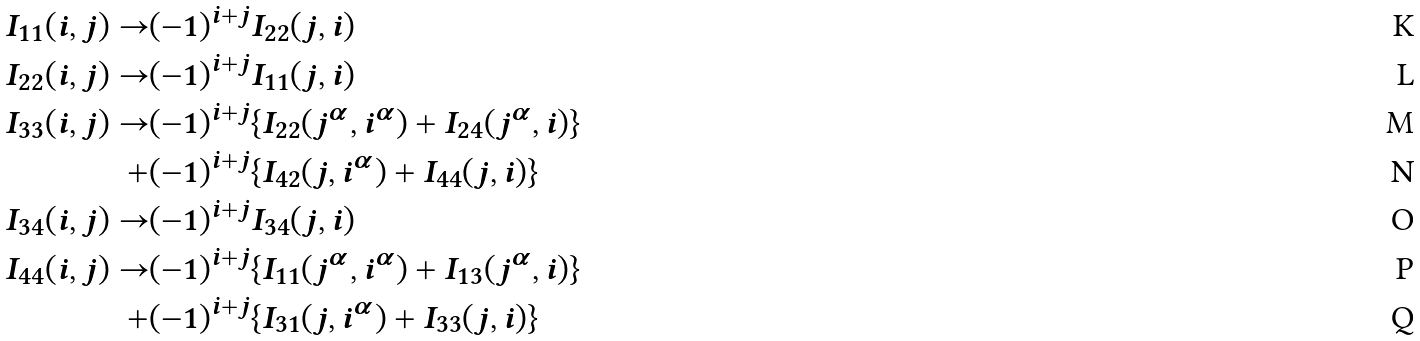Convert formula to latex. <formula><loc_0><loc_0><loc_500><loc_500>I _ { 1 1 } ( { i , j } ) \rightarrow & ( - 1 ) ^ { i + j } I _ { 2 2 } ( { j , i } ) \\ I _ { 2 2 } ( { i , j } ) \rightarrow & ( - 1 ) ^ { i + j } I _ { 1 1 } ( { j , i } ) \\ I _ { 3 3 } ( { i , j } ) \rightarrow & ( - 1 ) ^ { i + j } \{ I _ { 2 2 } ( { j ^ { \alpha } , i ^ { \alpha } } ) + I _ { 2 4 } ( { j ^ { \alpha } , i } ) \} \\ + & ( - 1 ) ^ { i + j } \{ I _ { 4 2 } ( { j , i ^ { \alpha } } ) + I _ { 4 4 } ( { j , i } ) \} \\ I _ { 3 4 } ( { i , j } ) \rightarrow & ( - 1 ) ^ { i + j } I _ { 3 4 } ( { j , i } ) \\ I _ { 4 4 } ( { i , j } ) \rightarrow & ( - 1 ) ^ { i + j } \{ I _ { 1 1 } ( { j ^ { \alpha } , i ^ { \alpha } } ) + I _ { 1 3 } ( { j ^ { \alpha } , i } ) \} \\ + & ( - 1 ) ^ { i + j } \{ I _ { 3 1 } ( { j , i ^ { \alpha } } ) + I _ { 3 3 } ( { j , i } ) \}</formula> 